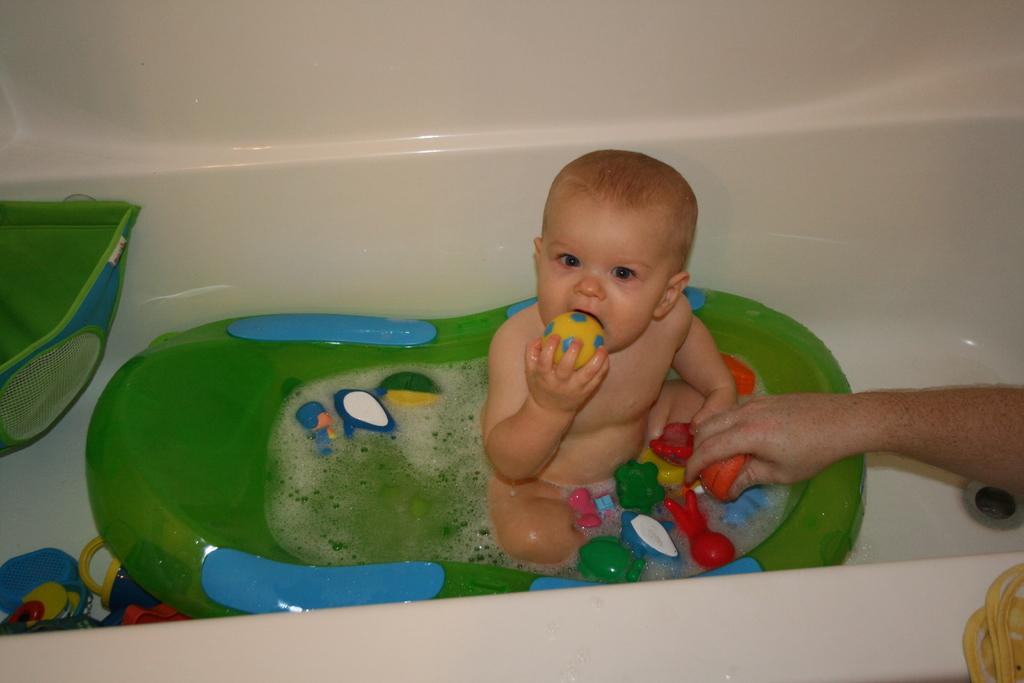What is the main subject of the image? There is a baby in the image. Where is the baby located in the image? The baby is sitting in a water tub. What else can be seen in the image besides the baby? There are many toys surrounding the baby. What type of acoustics can be heard in the image? There is no information about sounds or acoustics in the image, as it only shows a baby sitting in a water tub with toys. --- Facts: 1. There is a person holding a camera in the image. 2. The person is standing on a bridge. 3. There is a river below the bridge. 4. Mountains can be seen in the background. Absurd Topics: dance, sculpture, rainbow Conversation: What is the person in the image doing? The person is holding a camera in the image. Where is the person standing in the image? The person is standing on a bridge. What can be seen below the bridge in the image? There is a river below the bridge. What is visible in the background of the image? Mountains can be seen in the background. Reasoning: Let's think step by step in order to produce the conversation. We start by identifying the main subject of the image, which is the person holding a camera. Then, we describe the person's location and position, noting that they are standing on a bridge. Next, we mention the presence of a river below the bridge and mountains in the background, which adds context to the scene. Absurd Question/Answer: What type of dance is being performed on the bridge in the image? There is no indication of any dance or dancing in the image; the person is simply holding a camera. --- Facts: 1. There is a group of people in the image. 2. The people are wearing hats. 3. The people are holding hands. 4. There is a sign in the background. Absurd Topics: parachute, volcano, piano Conversation: What is the main subject of the image? There is a group of people in the image. What are the people wearing in the image? The people are wearing hats in the image. What are the people doing in the image? The people are holding hands in the image. What can be seen in the background of the image? There is a sign in the background. Reasoning: Let's think step by step in order to produce the conversation. We start by identifying the main subject of the image, which is the group of people. Then, we describe the people's appearance, noting that they are wearing hats. Next, we mention the people's actions, which is holding hands. Finally, we mention the presence of a sign in the background, which adds context to the scene. Absurd Question/Answer: 